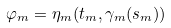Convert formula to latex. <formula><loc_0><loc_0><loc_500><loc_500>\varphi _ { m } = \eta _ { m } ( t _ { m } , \gamma _ { m } ( s _ { m } ) )</formula> 